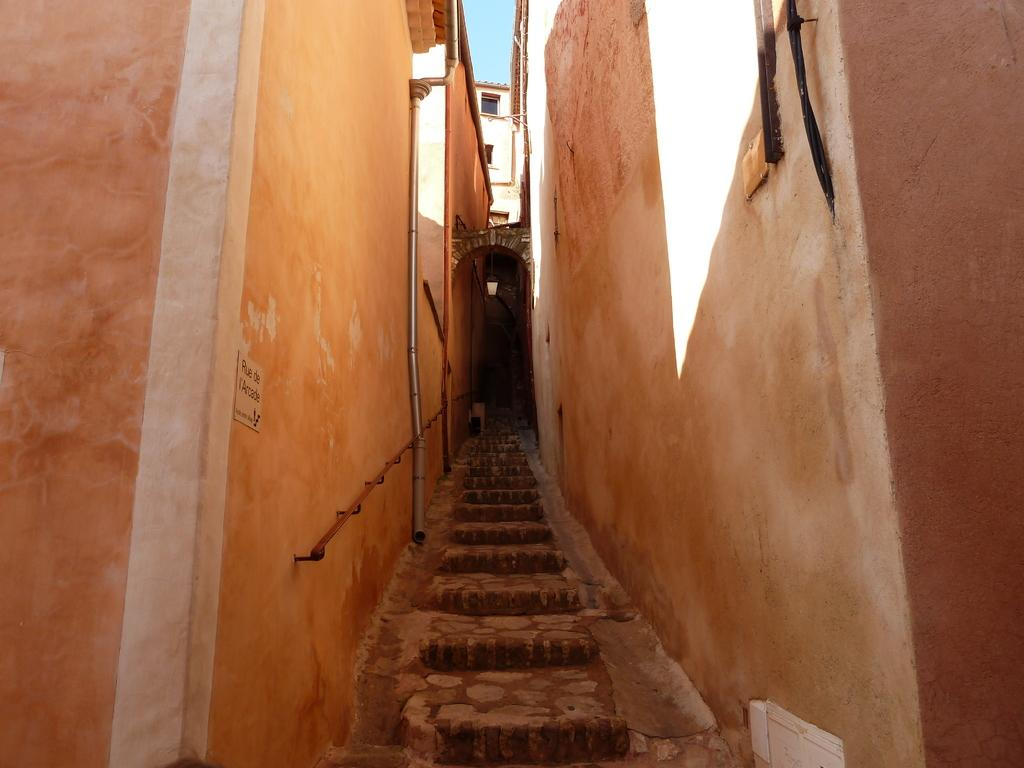What type of architectural feature is present in the image? There are steps in the image. What surrounds the steps in the image? There are walls of buildings on both sides of the steps. What can be seen in the background of the image? There is a building with glass windows in the background, and the sky is blue. What type of gold insect is present on the steps in the image? There is no gold insect present on the steps in the image. 